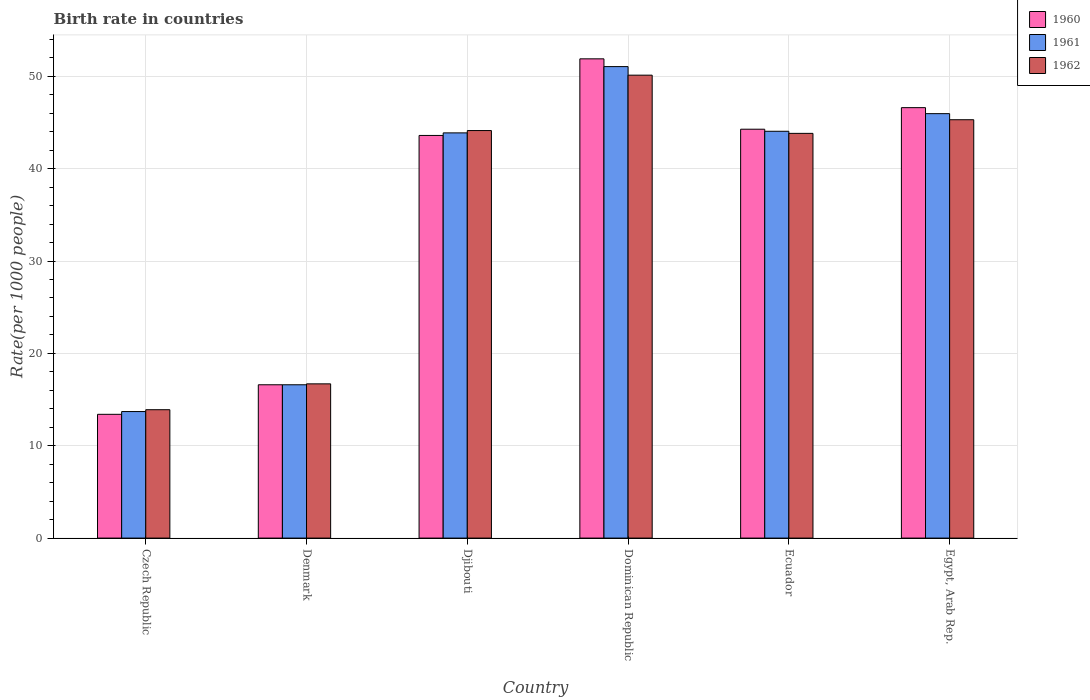How many different coloured bars are there?
Offer a very short reply. 3. How many bars are there on the 3rd tick from the left?
Keep it short and to the point. 3. How many bars are there on the 5th tick from the right?
Provide a succinct answer. 3. What is the label of the 2nd group of bars from the left?
Offer a very short reply. Denmark. What is the birth rate in 1962 in Ecuador?
Offer a very short reply. 43.82. Across all countries, what is the maximum birth rate in 1962?
Ensure brevity in your answer.  50.12. Across all countries, what is the minimum birth rate in 1961?
Offer a terse response. 13.7. In which country was the birth rate in 1962 maximum?
Your answer should be compact. Dominican Republic. In which country was the birth rate in 1961 minimum?
Provide a succinct answer. Czech Republic. What is the total birth rate in 1960 in the graph?
Your response must be concise. 216.36. What is the difference between the birth rate in 1961 in Denmark and that in Dominican Republic?
Your answer should be compact. -34.45. What is the difference between the birth rate in 1960 in Ecuador and the birth rate in 1962 in Denmark?
Offer a very short reply. 27.57. What is the average birth rate in 1961 per country?
Keep it short and to the point. 35.87. What is the difference between the birth rate of/in 1961 and birth rate of/in 1960 in Egypt, Arab Rep.?
Give a very brief answer. -0.65. What is the ratio of the birth rate in 1961 in Denmark to that in Dominican Republic?
Ensure brevity in your answer.  0.33. Is the difference between the birth rate in 1961 in Czech Republic and Egypt, Arab Rep. greater than the difference between the birth rate in 1960 in Czech Republic and Egypt, Arab Rep.?
Give a very brief answer. Yes. What is the difference between the highest and the second highest birth rate in 1961?
Keep it short and to the point. 7. What is the difference between the highest and the lowest birth rate in 1961?
Your answer should be very brief. 37.35. What does the 3rd bar from the right in Dominican Republic represents?
Your answer should be very brief. 1960. Are all the bars in the graph horizontal?
Ensure brevity in your answer.  No. What is the difference between two consecutive major ticks on the Y-axis?
Make the answer very short. 10. Are the values on the major ticks of Y-axis written in scientific E-notation?
Offer a very short reply. No. Does the graph contain grids?
Give a very brief answer. Yes. How many legend labels are there?
Offer a terse response. 3. What is the title of the graph?
Keep it short and to the point. Birth rate in countries. Does "1983" appear as one of the legend labels in the graph?
Keep it short and to the point. No. What is the label or title of the X-axis?
Give a very brief answer. Country. What is the label or title of the Y-axis?
Give a very brief answer. Rate(per 1000 people). What is the Rate(per 1000 people) in 1961 in Czech Republic?
Your answer should be compact. 13.7. What is the Rate(per 1000 people) in 1960 in Denmark?
Your answer should be compact. 16.6. What is the Rate(per 1000 people) in 1960 in Djibouti?
Make the answer very short. 43.59. What is the Rate(per 1000 people) of 1961 in Djibouti?
Your answer should be very brief. 43.87. What is the Rate(per 1000 people) in 1962 in Djibouti?
Make the answer very short. 44.12. What is the Rate(per 1000 people) in 1960 in Dominican Republic?
Provide a short and direct response. 51.89. What is the Rate(per 1000 people) in 1961 in Dominican Republic?
Give a very brief answer. 51.05. What is the Rate(per 1000 people) in 1962 in Dominican Republic?
Your answer should be very brief. 50.12. What is the Rate(per 1000 people) in 1960 in Ecuador?
Offer a terse response. 44.27. What is the Rate(per 1000 people) in 1961 in Ecuador?
Provide a succinct answer. 44.05. What is the Rate(per 1000 people) of 1962 in Ecuador?
Your answer should be very brief. 43.82. What is the Rate(per 1000 people) of 1960 in Egypt, Arab Rep.?
Make the answer very short. 46.6. What is the Rate(per 1000 people) in 1961 in Egypt, Arab Rep.?
Make the answer very short. 45.95. What is the Rate(per 1000 people) in 1962 in Egypt, Arab Rep.?
Ensure brevity in your answer.  45.3. Across all countries, what is the maximum Rate(per 1000 people) in 1960?
Provide a short and direct response. 51.89. Across all countries, what is the maximum Rate(per 1000 people) in 1961?
Provide a succinct answer. 51.05. Across all countries, what is the maximum Rate(per 1000 people) of 1962?
Your response must be concise. 50.12. Across all countries, what is the minimum Rate(per 1000 people) in 1962?
Ensure brevity in your answer.  13.9. What is the total Rate(per 1000 people) in 1960 in the graph?
Your response must be concise. 216.36. What is the total Rate(per 1000 people) of 1961 in the graph?
Offer a terse response. 215.22. What is the total Rate(per 1000 people) of 1962 in the graph?
Give a very brief answer. 213.96. What is the difference between the Rate(per 1000 people) in 1961 in Czech Republic and that in Denmark?
Provide a short and direct response. -2.9. What is the difference between the Rate(per 1000 people) of 1962 in Czech Republic and that in Denmark?
Keep it short and to the point. -2.8. What is the difference between the Rate(per 1000 people) of 1960 in Czech Republic and that in Djibouti?
Provide a succinct answer. -30.2. What is the difference between the Rate(per 1000 people) in 1961 in Czech Republic and that in Djibouti?
Provide a short and direct response. -30.17. What is the difference between the Rate(per 1000 people) in 1962 in Czech Republic and that in Djibouti?
Offer a very short reply. -30.23. What is the difference between the Rate(per 1000 people) in 1960 in Czech Republic and that in Dominican Republic?
Provide a short and direct response. -38.49. What is the difference between the Rate(per 1000 people) in 1961 in Czech Republic and that in Dominican Republic?
Offer a terse response. -37.35. What is the difference between the Rate(per 1000 people) of 1962 in Czech Republic and that in Dominican Republic?
Give a very brief answer. -36.22. What is the difference between the Rate(per 1000 people) in 1960 in Czech Republic and that in Ecuador?
Provide a short and direct response. -30.87. What is the difference between the Rate(per 1000 people) of 1961 in Czech Republic and that in Ecuador?
Your response must be concise. -30.35. What is the difference between the Rate(per 1000 people) in 1962 in Czech Republic and that in Ecuador?
Offer a very short reply. -29.92. What is the difference between the Rate(per 1000 people) of 1960 in Czech Republic and that in Egypt, Arab Rep.?
Provide a short and direct response. -33.2. What is the difference between the Rate(per 1000 people) of 1961 in Czech Republic and that in Egypt, Arab Rep.?
Provide a succinct answer. -32.25. What is the difference between the Rate(per 1000 people) in 1962 in Czech Republic and that in Egypt, Arab Rep.?
Offer a very short reply. -31.4. What is the difference between the Rate(per 1000 people) in 1960 in Denmark and that in Djibouti?
Provide a succinct answer. -27. What is the difference between the Rate(per 1000 people) of 1961 in Denmark and that in Djibouti?
Offer a terse response. -27.27. What is the difference between the Rate(per 1000 people) in 1962 in Denmark and that in Djibouti?
Your answer should be very brief. -27.43. What is the difference between the Rate(per 1000 people) in 1960 in Denmark and that in Dominican Republic?
Provide a short and direct response. -35.29. What is the difference between the Rate(per 1000 people) of 1961 in Denmark and that in Dominican Republic?
Your answer should be compact. -34.45. What is the difference between the Rate(per 1000 people) of 1962 in Denmark and that in Dominican Republic?
Make the answer very short. -33.42. What is the difference between the Rate(per 1000 people) of 1960 in Denmark and that in Ecuador?
Offer a terse response. -27.67. What is the difference between the Rate(per 1000 people) in 1961 in Denmark and that in Ecuador?
Give a very brief answer. -27.45. What is the difference between the Rate(per 1000 people) of 1962 in Denmark and that in Ecuador?
Keep it short and to the point. -27.12. What is the difference between the Rate(per 1000 people) in 1960 in Denmark and that in Egypt, Arab Rep.?
Make the answer very short. -30. What is the difference between the Rate(per 1000 people) in 1961 in Denmark and that in Egypt, Arab Rep.?
Make the answer very short. -29.35. What is the difference between the Rate(per 1000 people) of 1962 in Denmark and that in Egypt, Arab Rep.?
Your response must be concise. -28.6. What is the difference between the Rate(per 1000 people) in 1960 in Djibouti and that in Dominican Republic?
Offer a very short reply. -8.29. What is the difference between the Rate(per 1000 people) in 1961 in Djibouti and that in Dominican Republic?
Give a very brief answer. -7.18. What is the difference between the Rate(per 1000 people) in 1962 in Djibouti and that in Dominican Republic?
Your response must be concise. -6. What is the difference between the Rate(per 1000 people) in 1960 in Djibouti and that in Ecuador?
Your response must be concise. -0.68. What is the difference between the Rate(per 1000 people) of 1961 in Djibouti and that in Ecuador?
Your answer should be compact. -0.17. What is the difference between the Rate(per 1000 people) in 1962 in Djibouti and that in Ecuador?
Keep it short and to the point. 0.31. What is the difference between the Rate(per 1000 people) in 1960 in Djibouti and that in Egypt, Arab Rep.?
Provide a succinct answer. -3.01. What is the difference between the Rate(per 1000 people) of 1961 in Djibouti and that in Egypt, Arab Rep.?
Provide a short and direct response. -2.08. What is the difference between the Rate(per 1000 people) in 1962 in Djibouti and that in Egypt, Arab Rep.?
Provide a short and direct response. -1.17. What is the difference between the Rate(per 1000 people) in 1960 in Dominican Republic and that in Ecuador?
Provide a succinct answer. 7.62. What is the difference between the Rate(per 1000 people) of 1961 in Dominican Republic and that in Ecuador?
Make the answer very short. 7. What is the difference between the Rate(per 1000 people) in 1962 in Dominican Republic and that in Ecuador?
Your response must be concise. 6.3. What is the difference between the Rate(per 1000 people) of 1960 in Dominican Republic and that in Egypt, Arab Rep.?
Make the answer very short. 5.28. What is the difference between the Rate(per 1000 people) in 1961 in Dominican Republic and that in Egypt, Arab Rep.?
Offer a terse response. 5.09. What is the difference between the Rate(per 1000 people) of 1962 in Dominican Republic and that in Egypt, Arab Rep.?
Provide a short and direct response. 4.83. What is the difference between the Rate(per 1000 people) of 1960 in Ecuador and that in Egypt, Arab Rep.?
Offer a terse response. -2.33. What is the difference between the Rate(per 1000 people) of 1961 in Ecuador and that in Egypt, Arab Rep.?
Your answer should be compact. -1.91. What is the difference between the Rate(per 1000 people) of 1962 in Ecuador and that in Egypt, Arab Rep.?
Provide a short and direct response. -1.48. What is the difference between the Rate(per 1000 people) of 1960 in Czech Republic and the Rate(per 1000 people) of 1962 in Denmark?
Offer a terse response. -3.3. What is the difference between the Rate(per 1000 people) of 1960 in Czech Republic and the Rate(per 1000 people) of 1961 in Djibouti?
Your answer should be compact. -30.47. What is the difference between the Rate(per 1000 people) in 1960 in Czech Republic and the Rate(per 1000 people) in 1962 in Djibouti?
Provide a succinct answer. -30.73. What is the difference between the Rate(per 1000 people) of 1961 in Czech Republic and the Rate(per 1000 people) of 1962 in Djibouti?
Offer a very short reply. -30.43. What is the difference between the Rate(per 1000 people) in 1960 in Czech Republic and the Rate(per 1000 people) in 1961 in Dominican Republic?
Your response must be concise. -37.65. What is the difference between the Rate(per 1000 people) of 1960 in Czech Republic and the Rate(per 1000 people) of 1962 in Dominican Republic?
Give a very brief answer. -36.72. What is the difference between the Rate(per 1000 people) in 1961 in Czech Republic and the Rate(per 1000 people) in 1962 in Dominican Republic?
Your answer should be compact. -36.42. What is the difference between the Rate(per 1000 people) of 1960 in Czech Republic and the Rate(per 1000 people) of 1961 in Ecuador?
Keep it short and to the point. -30.65. What is the difference between the Rate(per 1000 people) in 1960 in Czech Republic and the Rate(per 1000 people) in 1962 in Ecuador?
Your answer should be very brief. -30.42. What is the difference between the Rate(per 1000 people) of 1961 in Czech Republic and the Rate(per 1000 people) of 1962 in Ecuador?
Provide a short and direct response. -30.12. What is the difference between the Rate(per 1000 people) in 1960 in Czech Republic and the Rate(per 1000 people) in 1961 in Egypt, Arab Rep.?
Your answer should be compact. -32.55. What is the difference between the Rate(per 1000 people) of 1960 in Czech Republic and the Rate(per 1000 people) of 1962 in Egypt, Arab Rep.?
Give a very brief answer. -31.9. What is the difference between the Rate(per 1000 people) in 1961 in Czech Republic and the Rate(per 1000 people) in 1962 in Egypt, Arab Rep.?
Give a very brief answer. -31.6. What is the difference between the Rate(per 1000 people) of 1960 in Denmark and the Rate(per 1000 people) of 1961 in Djibouti?
Make the answer very short. -27.27. What is the difference between the Rate(per 1000 people) of 1960 in Denmark and the Rate(per 1000 people) of 1962 in Djibouti?
Your answer should be very brief. -27.52. What is the difference between the Rate(per 1000 people) of 1961 in Denmark and the Rate(per 1000 people) of 1962 in Djibouti?
Provide a succinct answer. -27.52. What is the difference between the Rate(per 1000 people) in 1960 in Denmark and the Rate(per 1000 people) in 1961 in Dominican Republic?
Ensure brevity in your answer.  -34.45. What is the difference between the Rate(per 1000 people) of 1960 in Denmark and the Rate(per 1000 people) of 1962 in Dominican Republic?
Offer a very short reply. -33.52. What is the difference between the Rate(per 1000 people) in 1961 in Denmark and the Rate(per 1000 people) in 1962 in Dominican Republic?
Provide a succinct answer. -33.52. What is the difference between the Rate(per 1000 people) in 1960 in Denmark and the Rate(per 1000 people) in 1961 in Ecuador?
Provide a succinct answer. -27.45. What is the difference between the Rate(per 1000 people) in 1960 in Denmark and the Rate(per 1000 people) in 1962 in Ecuador?
Offer a terse response. -27.22. What is the difference between the Rate(per 1000 people) in 1961 in Denmark and the Rate(per 1000 people) in 1962 in Ecuador?
Offer a very short reply. -27.22. What is the difference between the Rate(per 1000 people) of 1960 in Denmark and the Rate(per 1000 people) of 1961 in Egypt, Arab Rep.?
Offer a terse response. -29.35. What is the difference between the Rate(per 1000 people) in 1960 in Denmark and the Rate(per 1000 people) in 1962 in Egypt, Arab Rep.?
Keep it short and to the point. -28.7. What is the difference between the Rate(per 1000 people) in 1961 in Denmark and the Rate(per 1000 people) in 1962 in Egypt, Arab Rep.?
Offer a very short reply. -28.7. What is the difference between the Rate(per 1000 people) of 1960 in Djibouti and the Rate(per 1000 people) of 1961 in Dominican Republic?
Your answer should be compact. -7.45. What is the difference between the Rate(per 1000 people) of 1960 in Djibouti and the Rate(per 1000 people) of 1962 in Dominican Republic?
Keep it short and to the point. -6.53. What is the difference between the Rate(per 1000 people) of 1961 in Djibouti and the Rate(per 1000 people) of 1962 in Dominican Republic?
Your response must be concise. -6.25. What is the difference between the Rate(per 1000 people) in 1960 in Djibouti and the Rate(per 1000 people) in 1961 in Ecuador?
Make the answer very short. -0.45. What is the difference between the Rate(per 1000 people) of 1960 in Djibouti and the Rate(per 1000 people) of 1962 in Ecuador?
Your response must be concise. -0.22. What is the difference between the Rate(per 1000 people) of 1961 in Djibouti and the Rate(per 1000 people) of 1962 in Ecuador?
Offer a very short reply. 0.05. What is the difference between the Rate(per 1000 people) of 1960 in Djibouti and the Rate(per 1000 people) of 1961 in Egypt, Arab Rep.?
Provide a succinct answer. -2.36. What is the difference between the Rate(per 1000 people) of 1960 in Djibouti and the Rate(per 1000 people) of 1962 in Egypt, Arab Rep.?
Your answer should be compact. -1.7. What is the difference between the Rate(per 1000 people) of 1961 in Djibouti and the Rate(per 1000 people) of 1962 in Egypt, Arab Rep.?
Your answer should be very brief. -1.42. What is the difference between the Rate(per 1000 people) of 1960 in Dominican Republic and the Rate(per 1000 people) of 1961 in Ecuador?
Provide a short and direct response. 7.84. What is the difference between the Rate(per 1000 people) in 1960 in Dominican Republic and the Rate(per 1000 people) in 1962 in Ecuador?
Provide a succinct answer. 8.07. What is the difference between the Rate(per 1000 people) of 1961 in Dominican Republic and the Rate(per 1000 people) of 1962 in Ecuador?
Offer a terse response. 7.23. What is the difference between the Rate(per 1000 people) of 1960 in Dominican Republic and the Rate(per 1000 people) of 1961 in Egypt, Arab Rep.?
Provide a succinct answer. 5.93. What is the difference between the Rate(per 1000 people) of 1960 in Dominican Republic and the Rate(per 1000 people) of 1962 in Egypt, Arab Rep.?
Your response must be concise. 6.59. What is the difference between the Rate(per 1000 people) of 1961 in Dominican Republic and the Rate(per 1000 people) of 1962 in Egypt, Arab Rep.?
Offer a terse response. 5.75. What is the difference between the Rate(per 1000 people) in 1960 in Ecuador and the Rate(per 1000 people) in 1961 in Egypt, Arab Rep.?
Ensure brevity in your answer.  -1.68. What is the difference between the Rate(per 1000 people) of 1960 in Ecuador and the Rate(per 1000 people) of 1962 in Egypt, Arab Rep.?
Give a very brief answer. -1.03. What is the difference between the Rate(per 1000 people) of 1961 in Ecuador and the Rate(per 1000 people) of 1962 in Egypt, Arab Rep.?
Offer a very short reply. -1.25. What is the average Rate(per 1000 people) of 1960 per country?
Keep it short and to the point. 36.06. What is the average Rate(per 1000 people) of 1961 per country?
Your answer should be compact. 35.87. What is the average Rate(per 1000 people) of 1962 per country?
Make the answer very short. 35.66. What is the difference between the Rate(per 1000 people) of 1960 and Rate(per 1000 people) of 1962 in Czech Republic?
Make the answer very short. -0.5. What is the difference between the Rate(per 1000 people) in 1960 and Rate(per 1000 people) in 1961 in Denmark?
Offer a terse response. 0. What is the difference between the Rate(per 1000 people) of 1960 and Rate(per 1000 people) of 1962 in Denmark?
Ensure brevity in your answer.  -0.1. What is the difference between the Rate(per 1000 people) of 1960 and Rate(per 1000 people) of 1961 in Djibouti?
Make the answer very short. -0.28. What is the difference between the Rate(per 1000 people) in 1960 and Rate(per 1000 people) in 1962 in Djibouti?
Offer a terse response. -0.53. What is the difference between the Rate(per 1000 people) of 1961 and Rate(per 1000 people) of 1962 in Djibouti?
Give a very brief answer. -0.25. What is the difference between the Rate(per 1000 people) of 1960 and Rate(per 1000 people) of 1961 in Dominican Republic?
Offer a terse response. 0.84. What is the difference between the Rate(per 1000 people) of 1960 and Rate(per 1000 people) of 1962 in Dominican Republic?
Your answer should be very brief. 1.77. What is the difference between the Rate(per 1000 people) of 1961 and Rate(per 1000 people) of 1962 in Dominican Republic?
Your answer should be compact. 0.93. What is the difference between the Rate(per 1000 people) in 1960 and Rate(per 1000 people) in 1961 in Ecuador?
Give a very brief answer. 0.22. What is the difference between the Rate(per 1000 people) in 1960 and Rate(per 1000 people) in 1962 in Ecuador?
Give a very brief answer. 0.45. What is the difference between the Rate(per 1000 people) of 1961 and Rate(per 1000 people) of 1962 in Ecuador?
Give a very brief answer. 0.23. What is the difference between the Rate(per 1000 people) in 1960 and Rate(per 1000 people) in 1961 in Egypt, Arab Rep.?
Offer a very short reply. 0.65. What is the difference between the Rate(per 1000 people) of 1960 and Rate(per 1000 people) of 1962 in Egypt, Arab Rep.?
Ensure brevity in your answer.  1.31. What is the difference between the Rate(per 1000 people) of 1961 and Rate(per 1000 people) of 1962 in Egypt, Arab Rep.?
Make the answer very short. 0.66. What is the ratio of the Rate(per 1000 people) in 1960 in Czech Republic to that in Denmark?
Provide a short and direct response. 0.81. What is the ratio of the Rate(per 1000 people) of 1961 in Czech Republic to that in Denmark?
Ensure brevity in your answer.  0.83. What is the ratio of the Rate(per 1000 people) in 1962 in Czech Republic to that in Denmark?
Make the answer very short. 0.83. What is the ratio of the Rate(per 1000 people) of 1960 in Czech Republic to that in Djibouti?
Give a very brief answer. 0.31. What is the ratio of the Rate(per 1000 people) of 1961 in Czech Republic to that in Djibouti?
Make the answer very short. 0.31. What is the ratio of the Rate(per 1000 people) of 1962 in Czech Republic to that in Djibouti?
Offer a terse response. 0.32. What is the ratio of the Rate(per 1000 people) of 1960 in Czech Republic to that in Dominican Republic?
Provide a succinct answer. 0.26. What is the ratio of the Rate(per 1000 people) in 1961 in Czech Republic to that in Dominican Republic?
Make the answer very short. 0.27. What is the ratio of the Rate(per 1000 people) in 1962 in Czech Republic to that in Dominican Republic?
Your answer should be very brief. 0.28. What is the ratio of the Rate(per 1000 people) in 1960 in Czech Republic to that in Ecuador?
Offer a terse response. 0.3. What is the ratio of the Rate(per 1000 people) in 1961 in Czech Republic to that in Ecuador?
Make the answer very short. 0.31. What is the ratio of the Rate(per 1000 people) of 1962 in Czech Republic to that in Ecuador?
Ensure brevity in your answer.  0.32. What is the ratio of the Rate(per 1000 people) in 1960 in Czech Republic to that in Egypt, Arab Rep.?
Keep it short and to the point. 0.29. What is the ratio of the Rate(per 1000 people) in 1961 in Czech Republic to that in Egypt, Arab Rep.?
Provide a short and direct response. 0.3. What is the ratio of the Rate(per 1000 people) in 1962 in Czech Republic to that in Egypt, Arab Rep.?
Make the answer very short. 0.31. What is the ratio of the Rate(per 1000 people) of 1960 in Denmark to that in Djibouti?
Keep it short and to the point. 0.38. What is the ratio of the Rate(per 1000 people) in 1961 in Denmark to that in Djibouti?
Provide a short and direct response. 0.38. What is the ratio of the Rate(per 1000 people) in 1962 in Denmark to that in Djibouti?
Ensure brevity in your answer.  0.38. What is the ratio of the Rate(per 1000 people) in 1960 in Denmark to that in Dominican Republic?
Keep it short and to the point. 0.32. What is the ratio of the Rate(per 1000 people) of 1961 in Denmark to that in Dominican Republic?
Ensure brevity in your answer.  0.33. What is the ratio of the Rate(per 1000 people) of 1962 in Denmark to that in Dominican Republic?
Your answer should be very brief. 0.33. What is the ratio of the Rate(per 1000 people) in 1960 in Denmark to that in Ecuador?
Make the answer very short. 0.38. What is the ratio of the Rate(per 1000 people) in 1961 in Denmark to that in Ecuador?
Provide a short and direct response. 0.38. What is the ratio of the Rate(per 1000 people) of 1962 in Denmark to that in Ecuador?
Your answer should be compact. 0.38. What is the ratio of the Rate(per 1000 people) in 1960 in Denmark to that in Egypt, Arab Rep.?
Your answer should be very brief. 0.36. What is the ratio of the Rate(per 1000 people) in 1961 in Denmark to that in Egypt, Arab Rep.?
Offer a very short reply. 0.36. What is the ratio of the Rate(per 1000 people) in 1962 in Denmark to that in Egypt, Arab Rep.?
Offer a very short reply. 0.37. What is the ratio of the Rate(per 1000 people) of 1960 in Djibouti to that in Dominican Republic?
Provide a short and direct response. 0.84. What is the ratio of the Rate(per 1000 people) of 1961 in Djibouti to that in Dominican Republic?
Your response must be concise. 0.86. What is the ratio of the Rate(per 1000 people) of 1962 in Djibouti to that in Dominican Republic?
Offer a terse response. 0.88. What is the ratio of the Rate(per 1000 people) of 1960 in Djibouti to that in Ecuador?
Your answer should be very brief. 0.98. What is the ratio of the Rate(per 1000 people) in 1962 in Djibouti to that in Ecuador?
Offer a terse response. 1.01. What is the ratio of the Rate(per 1000 people) of 1960 in Djibouti to that in Egypt, Arab Rep.?
Offer a very short reply. 0.94. What is the ratio of the Rate(per 1000 people) in 1961 in Djibouti to that in Egypt, Arab Rep.?
Offer a very short reply. 0.95. What is the ratio of the Rate(per 1000 people) in 1962 in Djibouti to that in Egypt, Arab Rep.?
Keep it short and to the point. 0.97. What is the ratio of the Rate(per 1000 people) in 1960 in Dominican Republic to that in Ecuador?
Ensure brevity in your answer.  1.17. What is the ratio of the Rate(per 1000 people) in 1961 in Dominican Republic to that in Ecuador?
Provide a succinct answer. 1.16. What is the ratio of the Rate(per 1000 people) of 1962 in Dominican Republic to that in Ecuador?
Keep it short and to the point. 1.14. What is the ratio of the Rate(per 1000 people) in 1960 in Dominican Republic to that in Egypt, Arab Rep.?
Provide a short and direct response. 1.11. What is the ratio of the Rate(per 1000 people) of 1961 in Dominican Republic to that in Egypt, Arab Rep.?
Make the answer very short. 1.11. What is the ratio of the Rate(per 1000 people) in 1962 in Dominican Republic to that in Egypt, Arab Rep.?
Keep it short and to the point. 1.11. What is the ratio of the Rate(per 1000 people) in 1960 in Ecuador to that in Egypt, Arab Rep.?
Your answer should be very brief. 0.95. What is the ratio of the Rate(per 1000 people) in 1961 in Ecuador to that in Egypt, Arab Rep.?
Your response must be concise. 0.96. What is the ratio of the Rate(per 1000 people) in 1962 in Ecuador to that in Egypt, Arab Rep.?
Give a very brief answer. 0.97. What is the difference between the highest and the second highest Rate(per 1000 people) in 1960?
Provide a succinct answer. 5.28. What is the difference between the highest and the second highest Rate(per 1000 people) in 1961?
Offer a very short reply. 5.09. What is the difference between the highest and the second highest Rate(per 1000 people) of 1962?
Your answer should be compact. 4.83. What is the difference between the highest and the lowest Rate(per 1000 people) in 1960?
Offer a terse response. 38.49. What is the difference between the highest and the lowest Rate(per 1000 people) in 1961?
Your answer should be compact. 37.35. What is the difference between the highest and the lowest Rate(per 1000 people) in 1962?
Offer a very short reply. 36.22. 